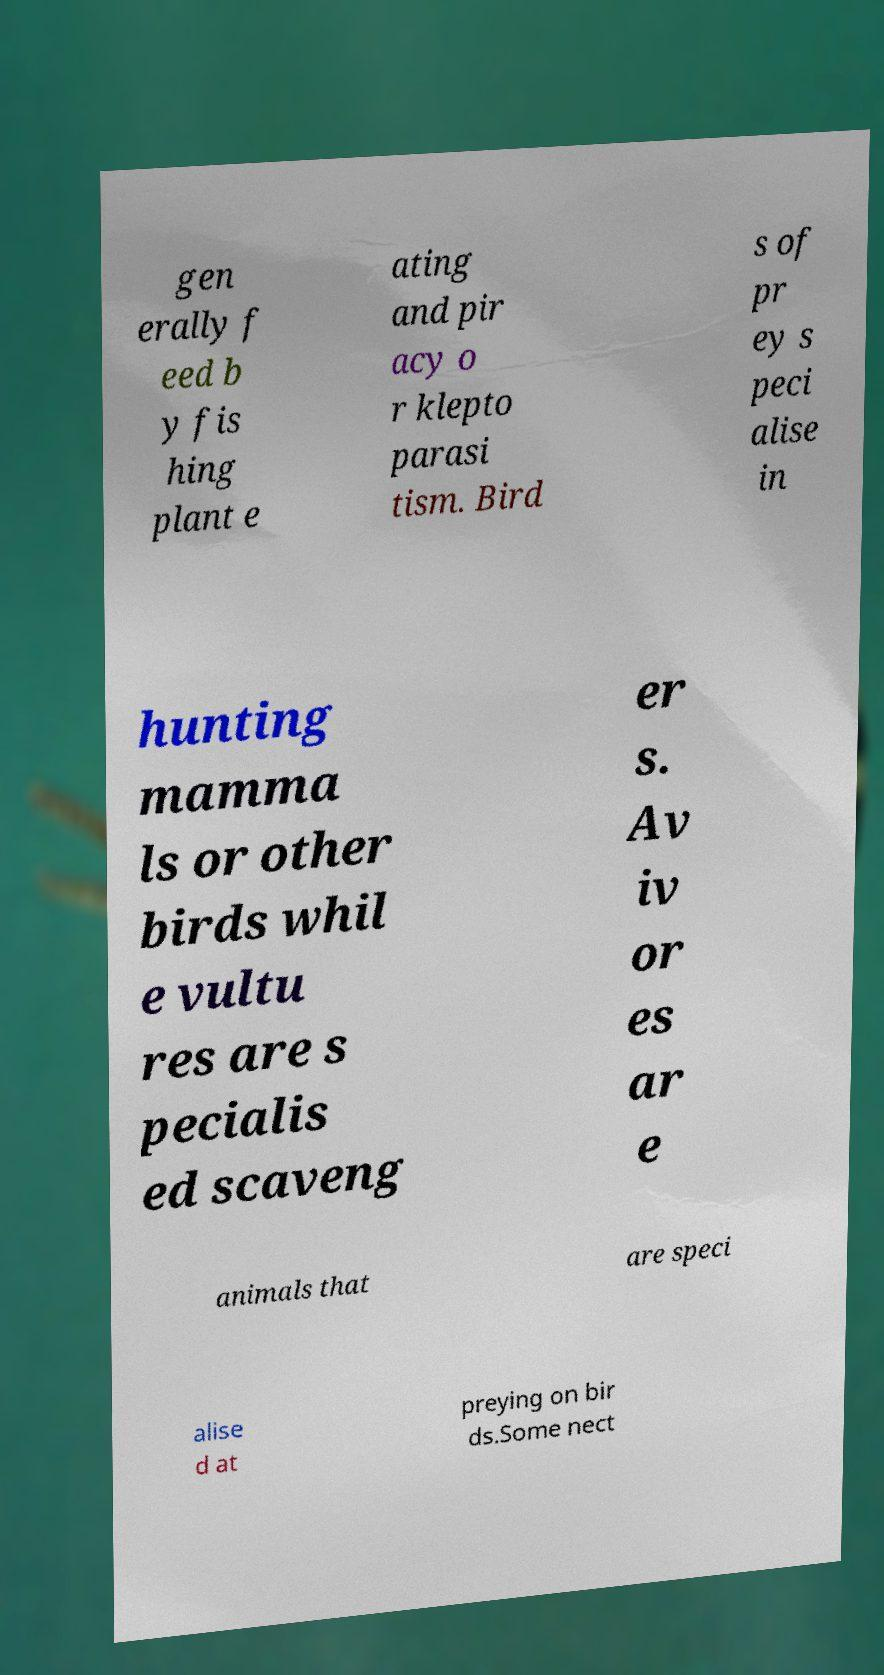Please identify and transcribe the text found in this image. gen erally f eed b y fis hing plant e ating and pir acy o r klepto parasi tism. Bird s of pr ey s peci alise in hunting mamma ls or other birds whil e vultu res are s pecialis ed scaveng er s. Av iv or es ar e animals that are speci alise d at preying on bir ds.Some nect 